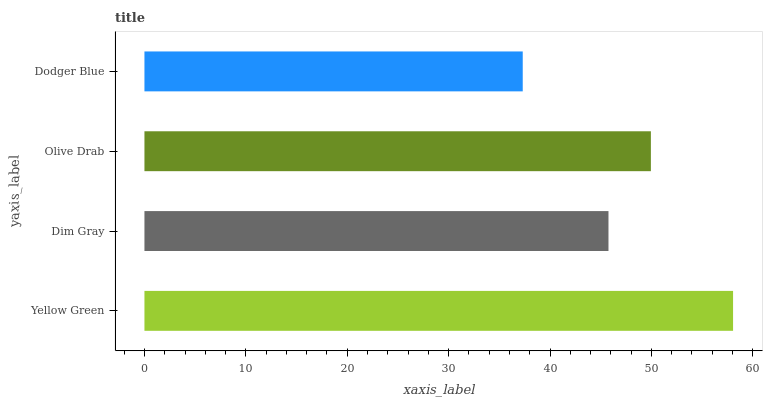Is Dodger Blue the minimum?
Answer yes or no. Yes. Is Yellow Green the maximum?
Answer yes or no. Yes. Is Dim Gray the minimum?
Answer yes or no. No. Is Dim Gray the maximum?
Answer yes or no. No. Is Yellow Green greater than Dim Gray?
Answer yes or no. Yes. Is Dim Gray less than Yellow Green?
Answer yes or no. Yes. Is Dim Gray greater than Yellow Green?
Answer yes or no. No. Is Yellow Green less than Dim Gray?
Answer yes or no. No. Is Olive Drab the high median?
Answer yes or no. Yes. Is Dim Gray the low median?
Answer yes or no. Yes. Is Dim Gray the high median?
Answer yes or no. No. Is Dodger Blue the low median?
Answer yes or no. No. 